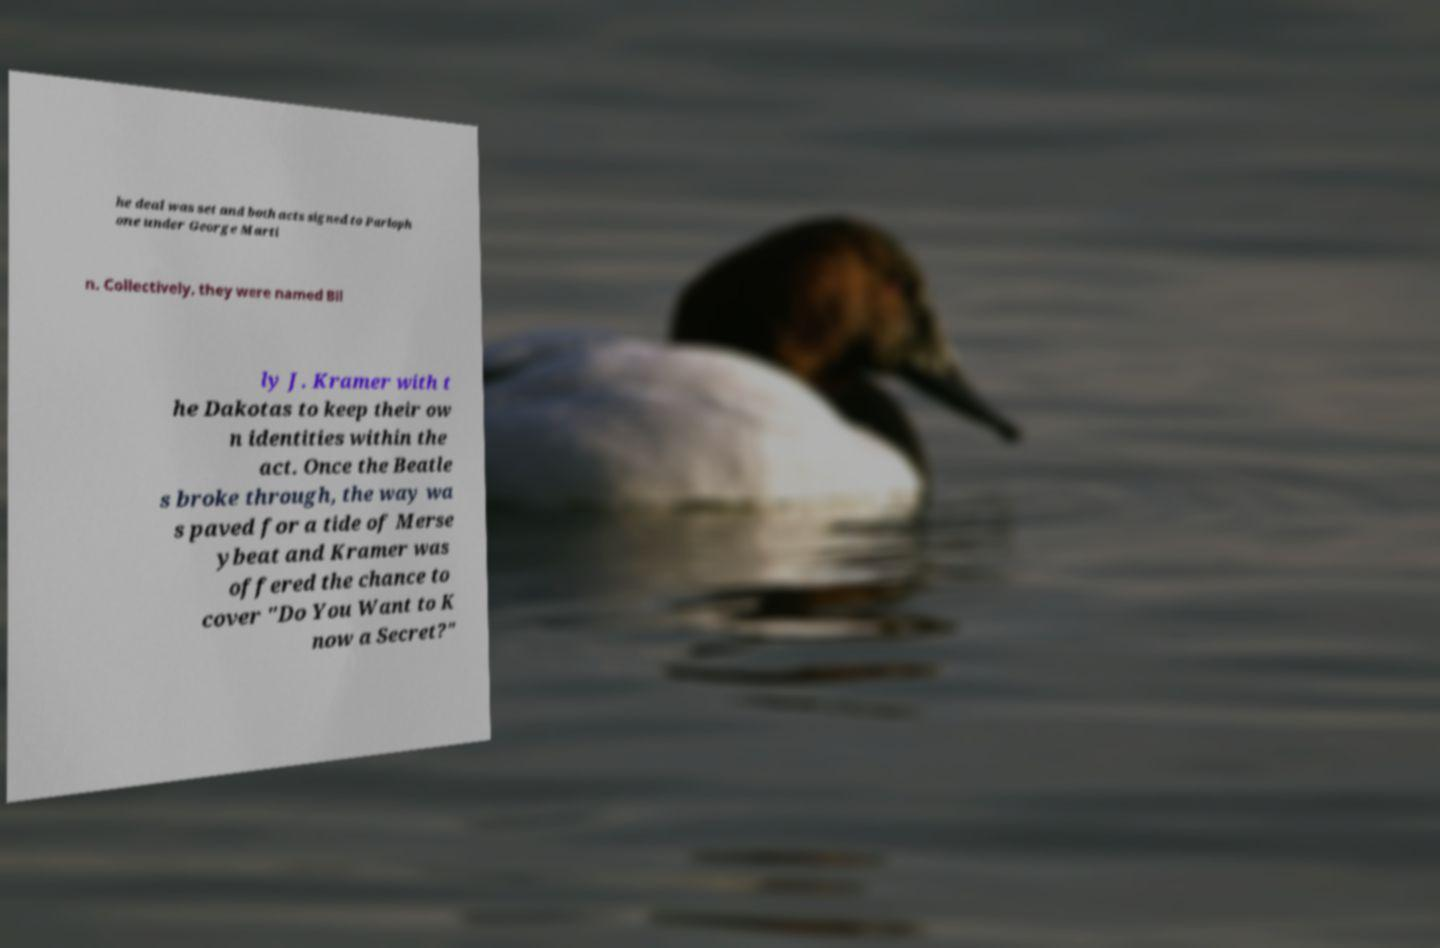For documentation purposes, I need the text within this image transcribed. Could you provide that? he deal was set and both acts signed to Parloph one under George Marti n. Collectively, they were named Bil ly J. Kramer with t he Dakotas to keep their ow n identities within the act. Once the Beatle s broke through, the way wa s paved for a tide of Merse ybeat and Kramer was offered the chance to cover "Do You Want to K now a Secret?" 